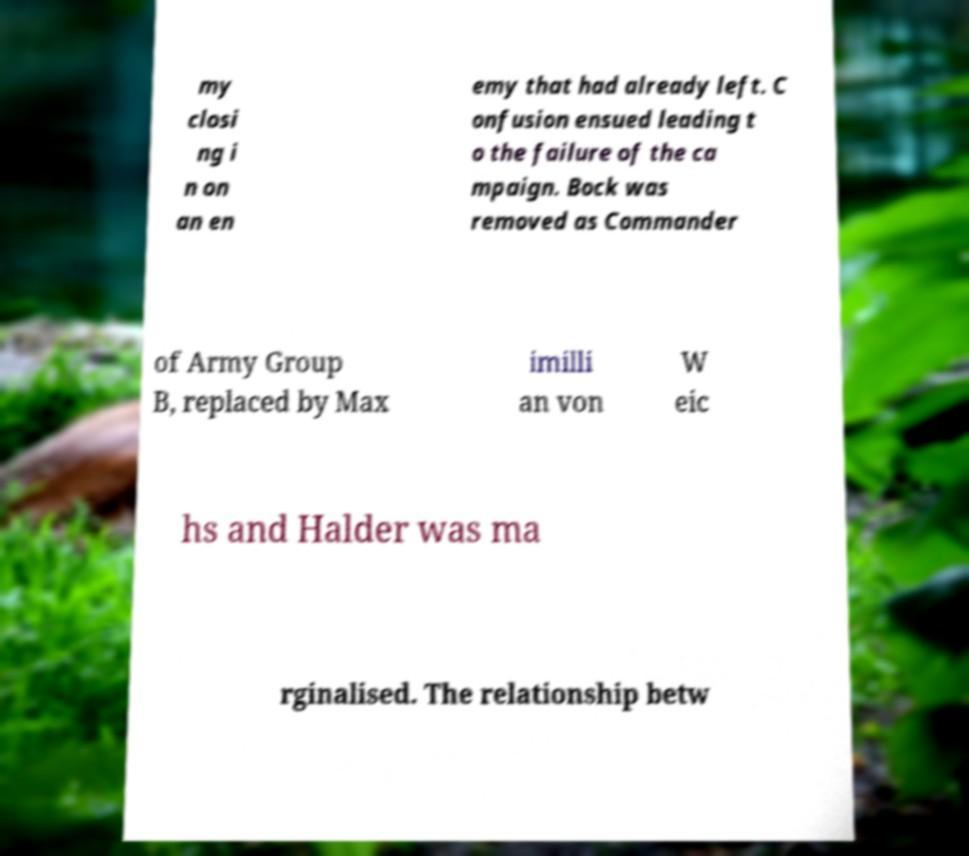Please identify and transcribe the text found in this image. my closi ng i n on an en emy that had already left. C onfusion ensued leading t o the failure of the ca mpaign. Bock was removed as Commander of Army Group B, replaced by Max imilli an von W eic hs and Halder was ma rginalised. The relationship betw 